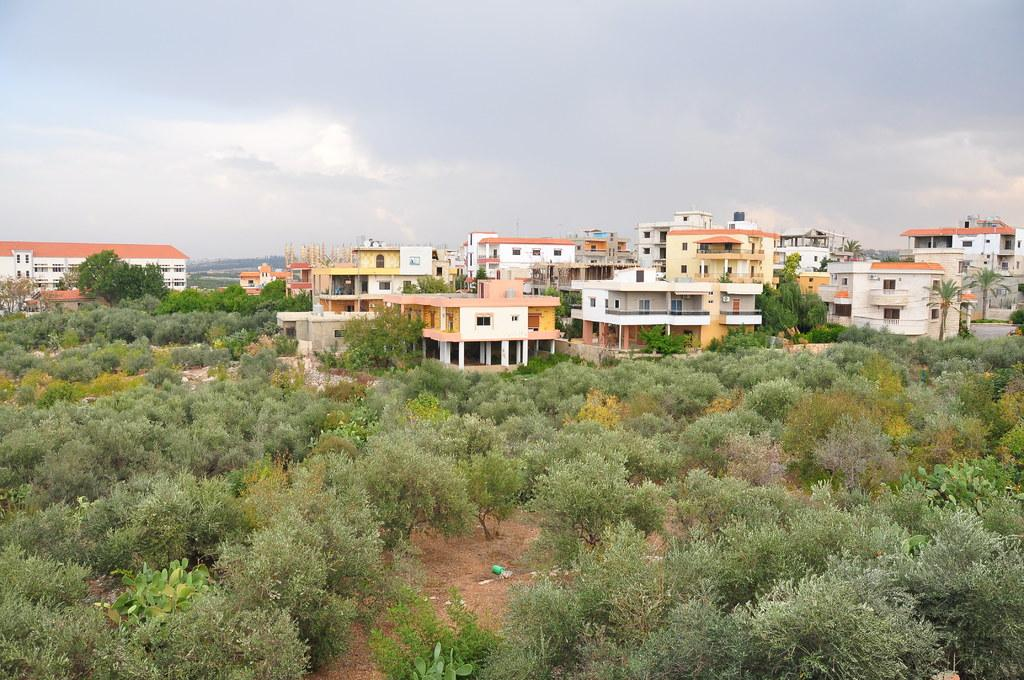What type of structures can be seen in the image? There are buildings in the image. What natural elements are present in the image? There are trees in the image. What architectural features can be observed in the image? There are pillars in the image. What openings are visible in the buildings? There are windows in the image. What is visible in the background of the image? The sky is visible in the background of the image. What atmospheric conditions can be observed in the sky? Clouds are present in the sky. Can you tell me which woman is sitting on the throne in the image? There is no woman or throne present in the image. What type of songs can be heard in the background of the image? There is no audio or music present in the image, so it is not possible to determine what songs might be heard. 